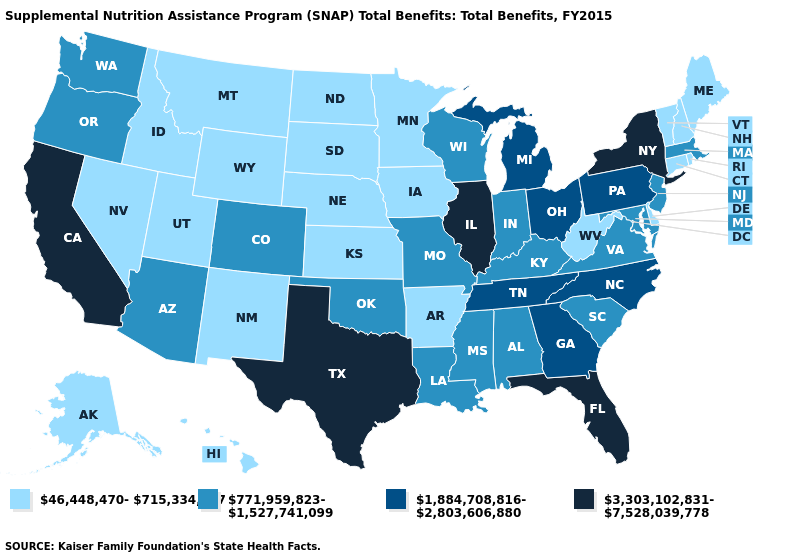Name the states that have a value in the range 1,884,708,816-2,803,606,880?
Short answer required. Georgia, Michigan, North Carolina, Ohio, Pennsylvania, Tennessee. Among the states that border Delaware , does Maryland have the highest value?
Keep it brief. No. Does Oregon have the lowest value in the West?
Short answer required. No. What is the value of Virginia?
Keep it brief. 771,959,823-1,527,741,099. Which states hav the highest value in the MidWest?
Be succinct. Illinois. Is the legend a continuous bar?
Keep it brief. No. Does Maine have the same value as Michigan?
Answer briefly. No. Is the legend a continuous bar?
Write a very short answer. No. Does Texas have a lower value than Missouri?
Give a very brief answer. No. What is the value of South Dakota?
Answer briefly. 46,448,470-715,334,947. Among the states that border Wisconsin , which have the lowest value?
Concise answer only. Iowa, Minnesota. Name the states that have a value in the range 46,448,470-715,334,947?
Give a very brief answer. Alaska, Arkansas, Connecticut, Delaware, Hawaii, Idaho, Iowa, Kansas, Maine, Minnesota, Montana, Nebraska, Nevada, New Hampshire, New Mexico, North Dakota, Rhode Island, South Dakota, Utah, Vermont, West Virginia, Wyoming. What is the value of West Virginia?
Answer briefly. 46,448,470-715,334,947. Name the states that have a value in the range 3,303,102,831-7,528,039,778?
Concise answer only. California, Florida, Illinois, New York, Texas. 